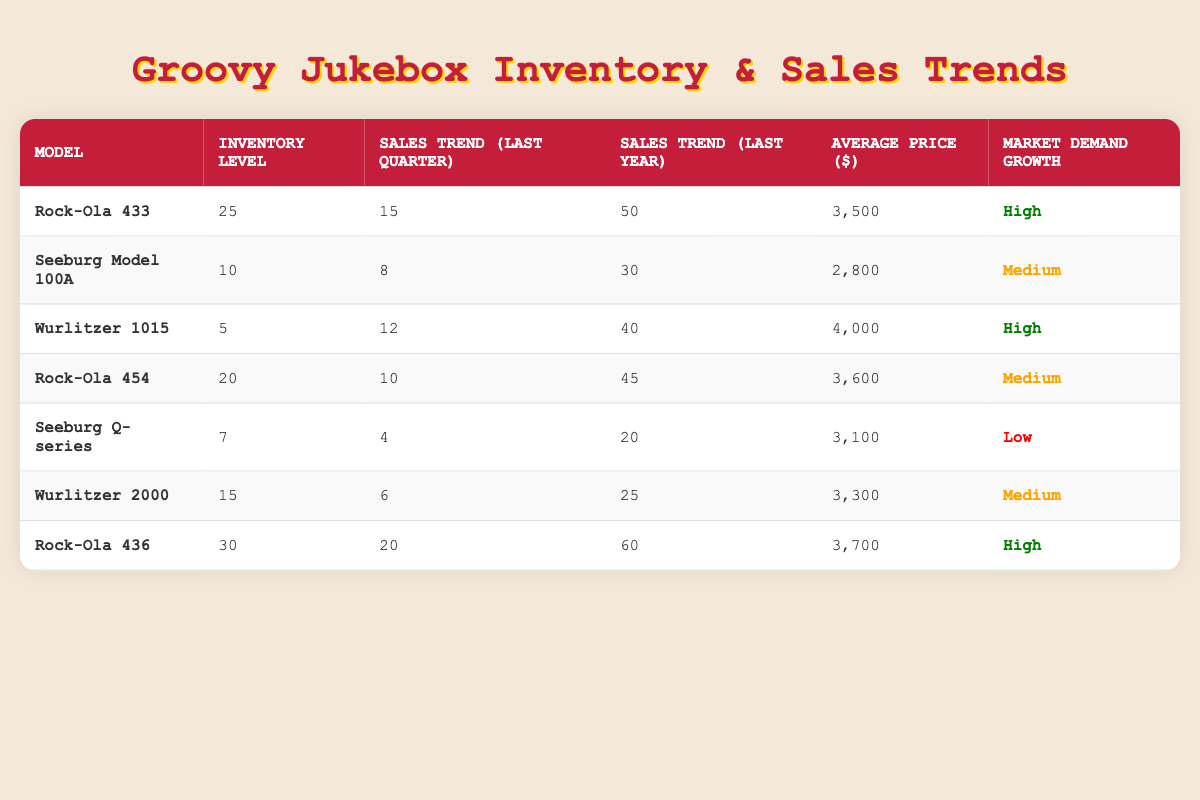What is the inventory level of the Wurlitzer 1015? The table shows the entry for Wurlitzer 1015 under the "Inventory Level" column, which lists the value of 5.
Answer: 5 How many jukebox models have a high market demand growth? The table lists models and their market demand growth; scanning through the entries, Rock-Ola 433, Wurlitzer 1015, and Rock-Ola 436 are marked as having high growth, totaling 3 models.
Answer: 3 What is the average price of the Rock-Ola 454? The table indicates that the average price for the Rock-Ola 454 is listed as 3600 in the "Average Price" column.
Answer: 3600 Which jukebox model has the lowest sales trend in the last quarter? By comparing the "Sales Trend (Last Quarter)" values, Seeburg Q-series has the lowest at 4, which is less than the values of all other models.
Answer: Seeburg Q-series Calculate the total inventory level of all jukebox models. To find the total inventory, sum the inventory levels: 25 (Rock-Ola 433) + 10 (Seeburg Model 100A) + 5 (Wurlitzer 1015) + 20 (Rock-Ola 454) + 7 (Seeburg Q-series) + 15 (Wurlitzer 2000) + 30 (Rock-Ola 436) equals 112.
Answer: 112 Is the average sales trend for last year of the Wurlitzer 2000 above or below 30? The average sales trend for the last year for Wurlitzer 2000 is stated as 25, which is below 30.
Answer: Below Which model has the highest average price, and what is that price? The table shows the average prices, and Wurlitzer 1015 has the highest listed price at 4000.
Answer: Wurlitzer 1015, 4000 What percentage of the inventory level does the Rock-Ola 436 represent in total inventory? The total inventory is 112, and Rock-Ola 436 has 30; the calculation is (30/112) * 100, which equals approximately 26.79%.
Answer: Approximately 26.79% How many more units of the Rock-Ola 433 are in inventory compared to the Seeburg Q-series? The Rock-Ola 433 has an inventory level of 25 while the Seeburg Q-series has 7; therefore, 25 - 7 equals 18 more units.
Answer: 18 If Wurlitzer 1015 sells 12 units, what will its new inventory be? The current inventory is 5, and if it sells 12 units, the new inventory would be 5 - 12, resulting in a negative inventory of -7.
Answer: -7 